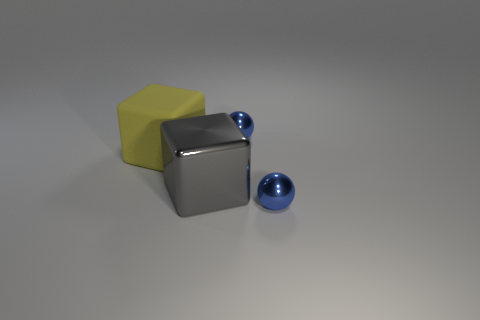What are the textures of the objects shown in the image? In the image, you can observe three distinct textures. The large, central cube has a smooth, reflective metallic surface. The block on the left has a matte, slightly rough texture that suggests it might be made of rubber. The two spheres appear to have a smooth, glossy finish, indicative of metal or glass with high reflectivity. 